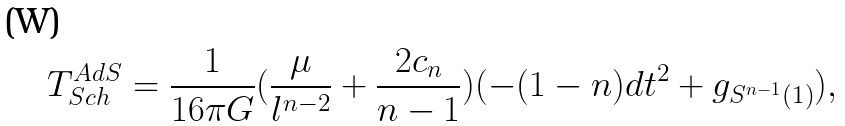Convert formula to latex. <formula><loc_0><loc_0><loc_500><loc_500>T _ { S c h } ^ { A d S } = \frac { 1 } { 1 6 \pi G } ( \frac { \mu } { l ^ { n - 2 } } + \frac { 2 c _ { n } } { n - 1 } ) ( - ( 1 - n ) d t ^ { 2 } + g _ { S ^ { n - 1 } ( 1 ) } ) ,</formula> 